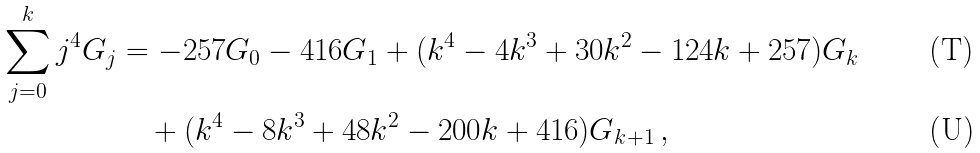<formula> <loc_0><loc_0><loc_500><loc_500>\sum _ { j = 0 } ^ { k } { j ^ { 4 } G _ { j } } & = - 2 5 7 G _ { 0 } - 4 1 6 G _ { 1 } + ( k ^ { 4 } - 4 k ^ { 3 } + 3 0 k ^ { 2 } - 1 2 4 k + 2 5 7 ) G _ { k } \\ & \quad + ( k ^ { 4 } - 8 k ^ { 3 } + 4 8 k ^ { 2 } - 2 0 0 k + 4 1 6 ) G _ { k + 1 } \, ,</formula> 